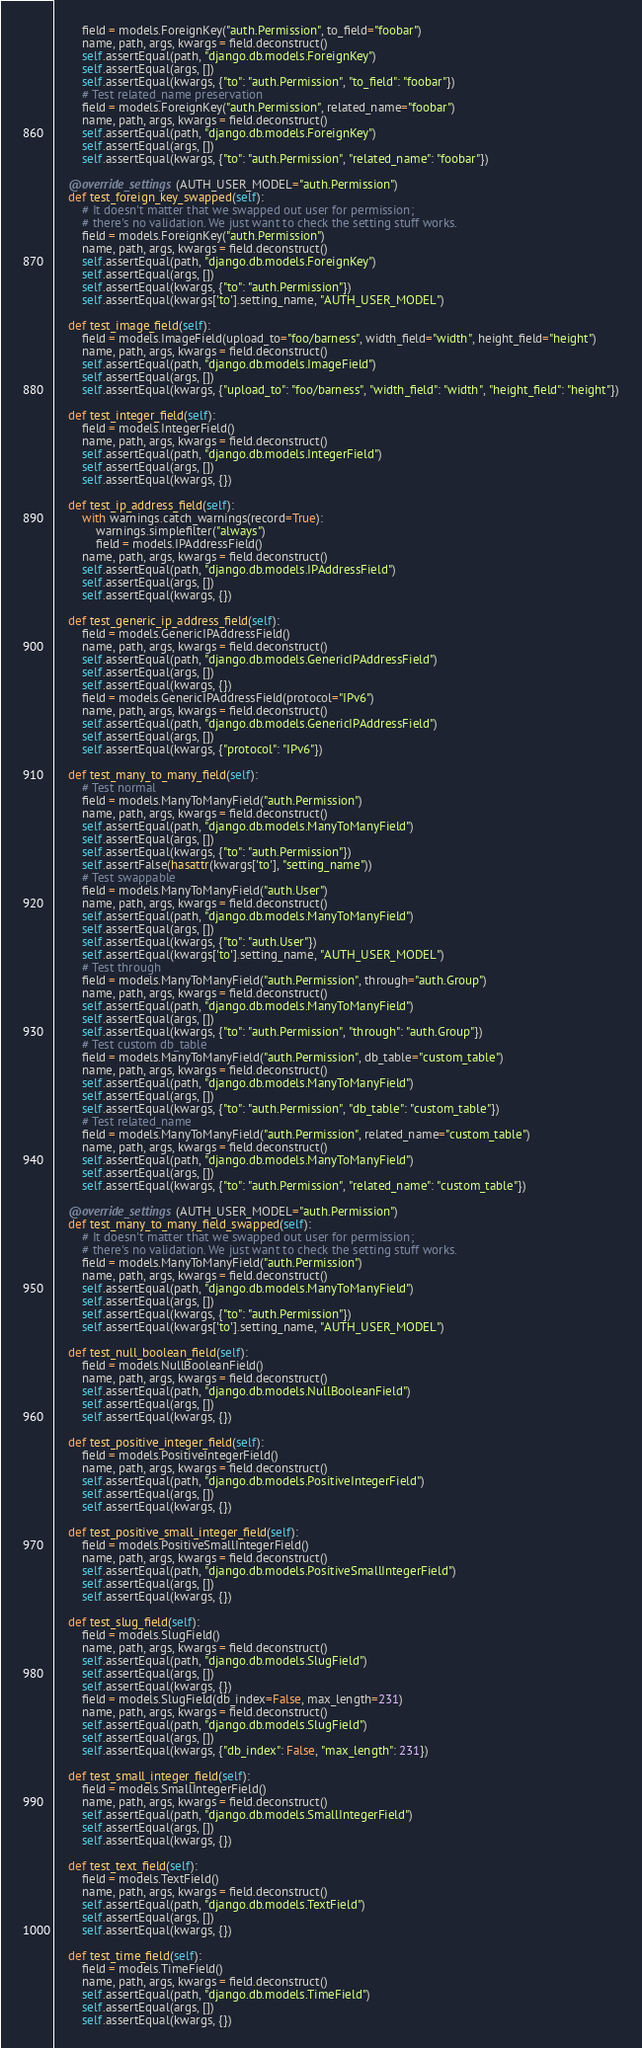<code> <loc_0><loc_0><loc_500><loc_500><_Python_>        field = models.ForeignKey("auth.Permission", to_field="foobar")
        name, path, args, kwargs = field.deconstruct()
        self.assertEqual(path, "django.db.models.ForeignKey")
        self.assertEqual(args, [])
        self.assertEqual(kwargs, {"to": "auth.Permission", "to_field": "foobar"})
        # Test related_name preservation
        field = models.ForeignKey("auth.Permission", related_name="foobar")
        name, path, args, kwargs = field.deconstruct()
        self.assertEqual(path, "django.db.models.ForeignKey")
        self.assertEqual(args, [])
        self.assertEqual(kwargs, {"to": "auth.Permission", "related_name": "foobar"})

    @override_settings(AUTH_USER_MODEL="auth.Permission")
    def test_foreign_key_swapped(self):
        # It doesn't matter that we swapped out user for permission;
        # there's no validation. We just want to check the setting stuff works.
        field = models.ForeignKey("auth.Permission")
        name, path, args, kwargs = field.deconstruct()
        self.assertEqual(path, "django.db.models.ForeignKey")
        self.assertEqual(args, [])
        self.assertEqual(kwargs, {"to": "auth.Permission"})
        self.assertEqual(kwargs['to'].setting_name, "AUTH_USER_MODEL")

    def test_image_field(self):
        field = models.ImageField(upload_to="foo/barness", width_field="width", height_field="height")
        name, path, args, kwargs = field.deconstruct()
        self.assertEqual(path, "django.db.models.ImageField")
        self.assertEqual(args, [])
        self.assertEqual(kwargs, {"upload_to": "foo/barness", "width_field": "width", "height_field": "height"})

    def test_integer_field(self):
        field = models.IntegerField()
        name, path, args, kwargs = field.deconstruct()
        self.assertEqual(path, "django.db.models.IntegerField")
        self.assertEqual(args, [])
        self.assertEqual(kwargs, {})

    def test_ip_address_field(self):
        with warnings.catch_warnings(record=True):
            warnings.simplefilter("always")
            field = models.IPAddressField()
        name, path, args, kwargs = field.deconstruct()
        self.assertEqual(path, "django.db.models.IPAddressField")
        self.assertEqual(args, [])
        self.assertEqual(kwargs, {})

    def test_generic_ip_address_field(self):
        field = models.GenericIPAddressField()
        name, path, args, kwargs = field.deconstruct()
        self.assertEqual(path, "django.db.models.GenericIPAddressField")
        self.assertEqual(args, [])
        self.assertEqual(kwargs, {})
        field = models.GenericIPAddressField(protocol="IPv6")
        name, path, args, kwargs = field.deconstruct()
        self.assertEqual(path, "django.db.models.GenericIPAddressField")
        self.assertEqual(args, [])
        self.assertEqual(kwargs, {"protocol": "IPv6"})

    def test_many_to_many_field(self):
        # Test normal
        field = models.ManyToManyField("auth.Permission")
        name, path, args, kwargs = field.deconstruct()
        self.assertEqual(path, "django.db.models.ManyToManyField")
        self.assertEqual(args, [])
        self.assertEqual(kwargs, {"to": "auth.Permission"})
        self.assertFalse(hasattr(kwargs['to'], "setting_name"))
        # Test swappable
        field = models.ManyToManyField("auth.User")
        name, path, args, kwargs = field.deconstruct()
        self.assertEqual(path, "django.db.models.ManyToManyField")
        self.assertEqual(args, [])
        self.assertEqual(kwargs, {"to": "auth.User"})
        self.assertEqual(kwargs['to'].setting_name, "AUTH_USER_MODEL")
        # Test through
        field = models.ManyToManyField("auth.Permission", through="auth.Group")
        name, path, args, kwargs = field.deconstruct()
        self.assertEqual(path, "django.db.models.ManyToManyField")
        self.assertEqual(args, [])
        self.assertEqual(kwargs, {"to": "auth.Permission", "through": "auth.Group"})
        # Test custom db_table
        field = models.ManyToManyField("auth.Permission", db_table="custom_table")
        name, path, args, kwargs = field.deconstruct()
        self.assertEqual(path, "django.db.models.ManyToManyField")
        self.assertEqual(args, [])
        self.assertEqual(kwargs, {"to": "auth.Permission", "db_table": "custom_table"})
        # Test related_name
        field = models.ManyToManyField("auth.Permission", related_name="custom_table")
        name, path, args, kwargs = field.deconstruct()
        self.assertEqual(path, "django.db.models.ManyToManyField")
        self.assertEqual(args, [])
        self.assertEqual(kwargs, {"to": "auth.Permission", "related_name": "custom_table"})

    @override_settings(AUTH_USER_MODEL="auth.Permission")
    def test_many_to_many_field_swapped(self):
        # It doesn't matter that we swapped out user for permission;
        # there's no validation. We just want to check the setting stuff works.
        field = models.ManyToManyField("auth.Permission")
        name, path, args, kwargs = field.deconstruct()
        self.assertEqual(path, "django.db.models.ManyToManyField")
        self.assertEqual(args, [])
        self.assertEqual(kwargs, {"to": "auth.Permission"})
        self.assertEqual(kwargs['to'].setting_name, "AUTH_USER_MODEL")

    def test_null_boolean_field(self):
        field = models.NullBooleanField()
        name, path, args, kwargs = field.deconstruct()
        self.assertEqual(path, "django.db.models.NullBooleanField")
        self.assertEqual(args, [])
        self.assertEqual(kwargs, {})

    def test_positive_integer_field(self):
        field = models.PositiveIntegerField()
        name, path, args, kwargs = field.deconstruct()
        self.assertEqual(path, "django.db.models.PositiveIntegerField")
        self.assertEqual(args, [])
        self.assertEqual(kwargs, {})

    def test_positive_small_integer_field(self):
        field = models.PositiveSmallIntegerField()
        name, path, args, kwargs = field.deconstruct()
        self.assertEqual(path, "django.db.models.PositiveSmallIntegerField")
        self.assertEqual(args, [])
        self.assertEqual(kwargs, {})

    def test_slug_field(self):
        field = models.SlugField()
        name, path, args, kwargs = field.deconstruct()
        self.assertEqual(path, "django.db.models.SlugField")
        self.assertEqual(args, [])
        self.assertEqual(kwargs, {})
        field = models.SlugField(db_index=False, max_length=231)
        name, path, args, kwargs = field.deconstruct()
        self.assertEqual(path, "django.db.models.SlugField")
        self.assertEqual(args, [])
        self.assertEqual(kwargs, {"db_index": False, "max_length": 231})

    def test_small_integer_field(self):
        field = models.SmallIntegerField()
        name, path, args, kwargs = field.deconstruct()
        self.assertEqual(path, "django.db.models.SmallIntegerField")
        self.assertEqual(args, [])
        self.assertEqual(kwargs, {})

    def test_text_field(self):
        field = models.TextField()
        name, path, args, kwargs = field.deconstruct()
        self.assertEqual(path, "django.db.models.TextField")
        self.assertEqual(args, [])
        self.assertEqual(kwargs, {})

    def test_time_field(self):
        field = models.TimeField()
        name, path, args, kwargs = field.deconstruct()
        self.assertEqual(path, "django.db.models.TimeField")
        self.assertEqual(args, [])
        self.assertEqual(kwargs, {})
</code> 